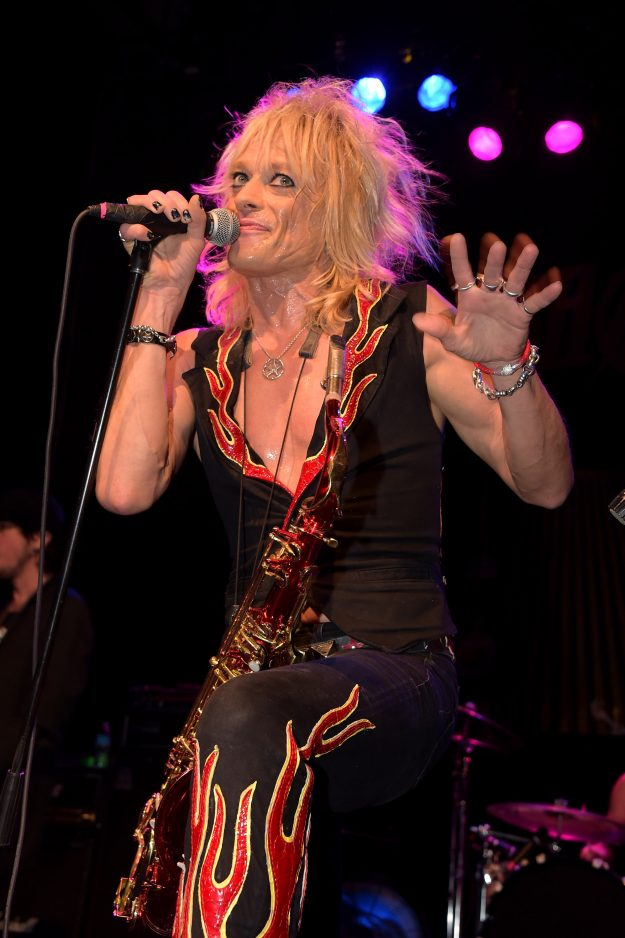What does the performer's choice of jewelry and accessories indicate about their personal style or the image they wish to convey? The performer's choice of jewelry and accessories, including several bracelets on both wrists and a prominent necklace, reflects a distinctive personal style connected to rock or glam rock aesthetics. This selection suggests a desire to project an image of edginess and individualism, traits often associated with rock and glam rock cultures. The varied designs of the bracelets imply a casual yet intentional approach to fashion, mirroring a blend of authenticity and nonconformity. This look likely aims to resonate with an audience that values genuine expression over polished appearance, reinforcing a rebellious and relatable persona. 